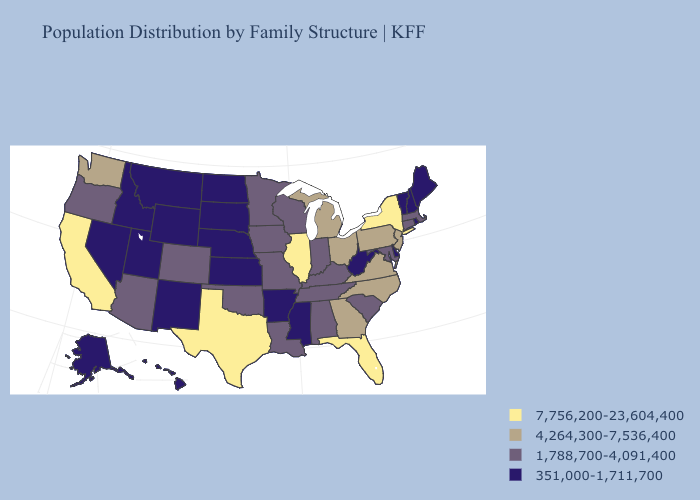Name the states that have a value in the range 351,000-1,711,700?
Keep it brief. Alaska, Arkansas, Delaware, Hawaii, Idaho, Kansas, Maine, Mississippi, Montana, Nebraska, Nevada, New Hampshire, New Mexico, North Dakota, Rhode Island, South Dakota, Utah, Vermont, West Virginia, Wyoming. Does Pennsylvania have the highest value in the Northeast?
Give a very brief answer. No. What is the lowest value in the South?
Short answer required. 351,000-1,711,700. What is the lowest value in the USA?
Be succinct. 351,000-1,711,700. Among the states that border Washington , which have the lowest value?
Short answer required. Idaho. How many symbols are there in the legend?
Keep it brief. 4. Which states have the lowest value in the USA?
Keep it brief. Alaska, Arkansas, Delaware, Hawaii, Idaho, Kansas, Maine, Mississippi, Montana, Nebraska, Nevada, New Hampshire, New Mexico, North Dakota, Rhode Island, South Dakota, Utah, Vermont, West Virginia, Wyoming. What is the highest value in the MidWest ?
Answer briefly. 7,756,200-23,604,400. What is the highest value in the USA?
Short answer required. 7,756,200-23,604,400. What is the value of Connecticut?
Write a very short answer. 1,788,700-4,091,400. Which states have the lowest value in the West?
Quick response, please. Alaska, Hawaii, Idaho, Montana, Nevada, New Mexico, Utah, Wyoming. Is the legend a continuous bar?
Give a very brief answer. No. What is the value of South Dakota?
Concise answer only. 351,000-1,711,700. Which states have the lowest value in the South?
Be succinct. Arkansas, Delaware, Mississippi, West Virginia. 